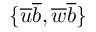Convert formula to latex. <formula><loc_0><loc_0><loc_500><loc_500>\{ \overline { u } \overline { b } , \overline { w } \overline { b } \}</formula> 